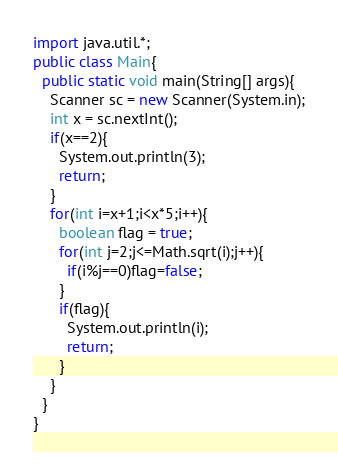<code> <loc_0><loc_0><loc_500><loc_500><_Java_>import java.util.*;
public class Main{
  public static void main(String[] args){
    Scanner sc = new Scanner(System.in);
    int x = sc.nextInt();
    if(x==2){
      System.out.println(3);
      return;
    }
    for(int i=x+1;i<x*5;i++){
      boolean flag = true;
      for(int j=2;j<=Math.sqrt(i);j++){
        if(i%j==0)flag=false;
      }
      if(flag){
        System.out.println(i);
        return;
      }
    }
  }
}
</code> 